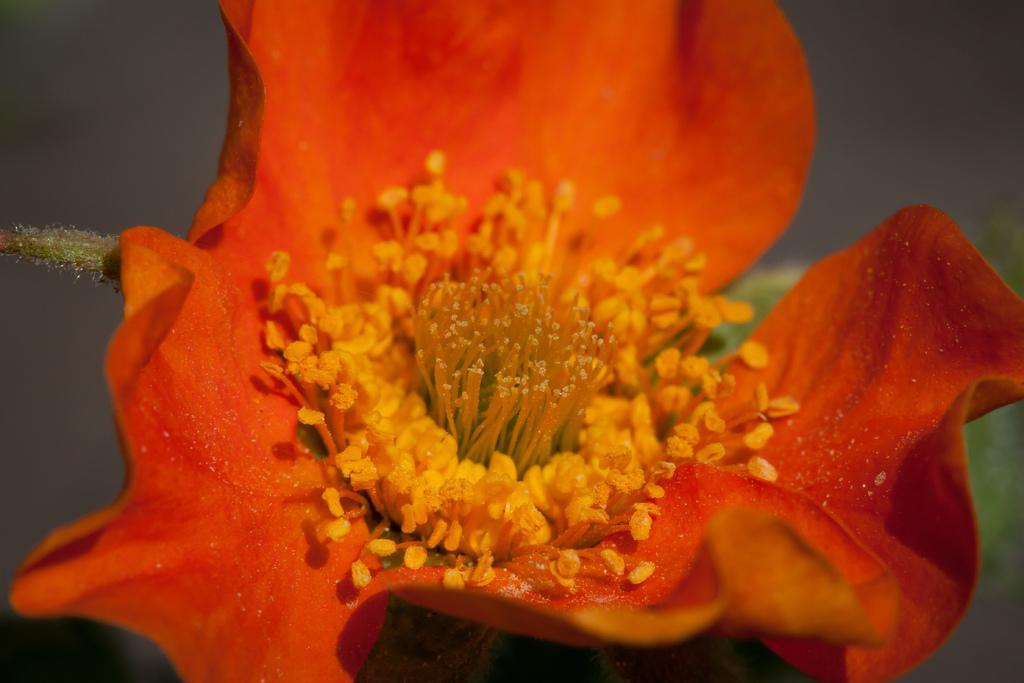Please provide a concise description of this image. In this image in the foreground there is one flower, which is in orange color and there is a blurry background. 